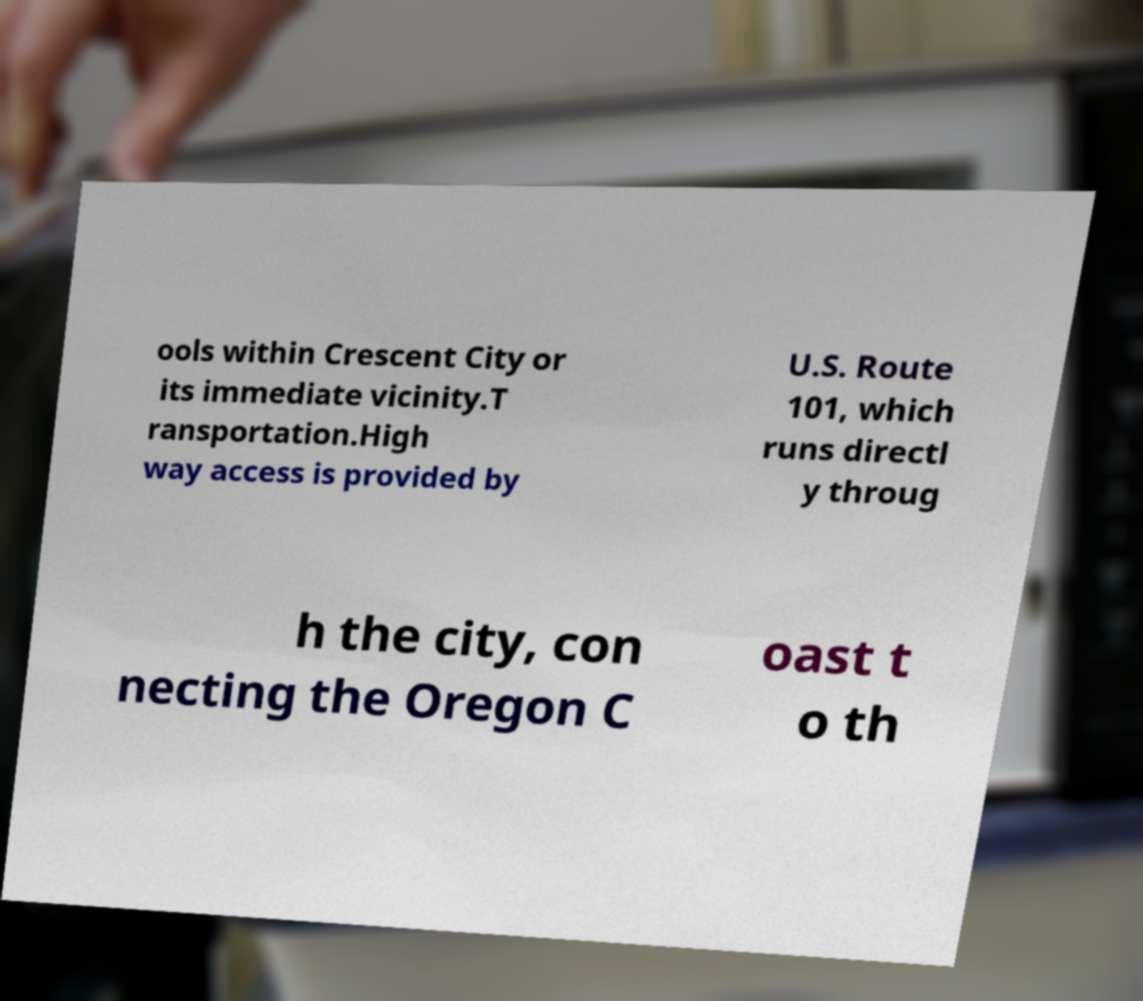Please read and relay the text visible in this image. What does it say? ools within Crescent City or its immediate vicinity.T ransportation.High way access is provided by U.S. Route 101, which runs directl y throug h the city, con necting the Oregon C oast t o th 